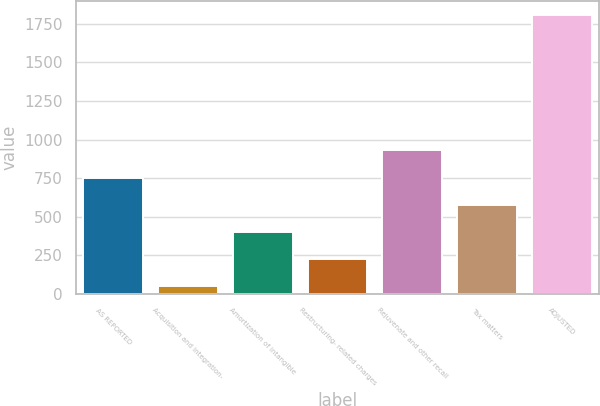<chart> <loc_0><loc_0><loc_500><loc_500><bar_chart><fcel>AS REPORTED<fcel>Acquisition and integration-<fcel>Amortization of intangible<fcel>Restructuring- related charges<fcel>Rejuvenate and other recall<fcel>Tax matters<fcel>ADJUSTED<nl><fcel>754<fcel>50<fcel>402<fcel>226<fcel>930<fcel>578<fcel>1810<nl></chart> 